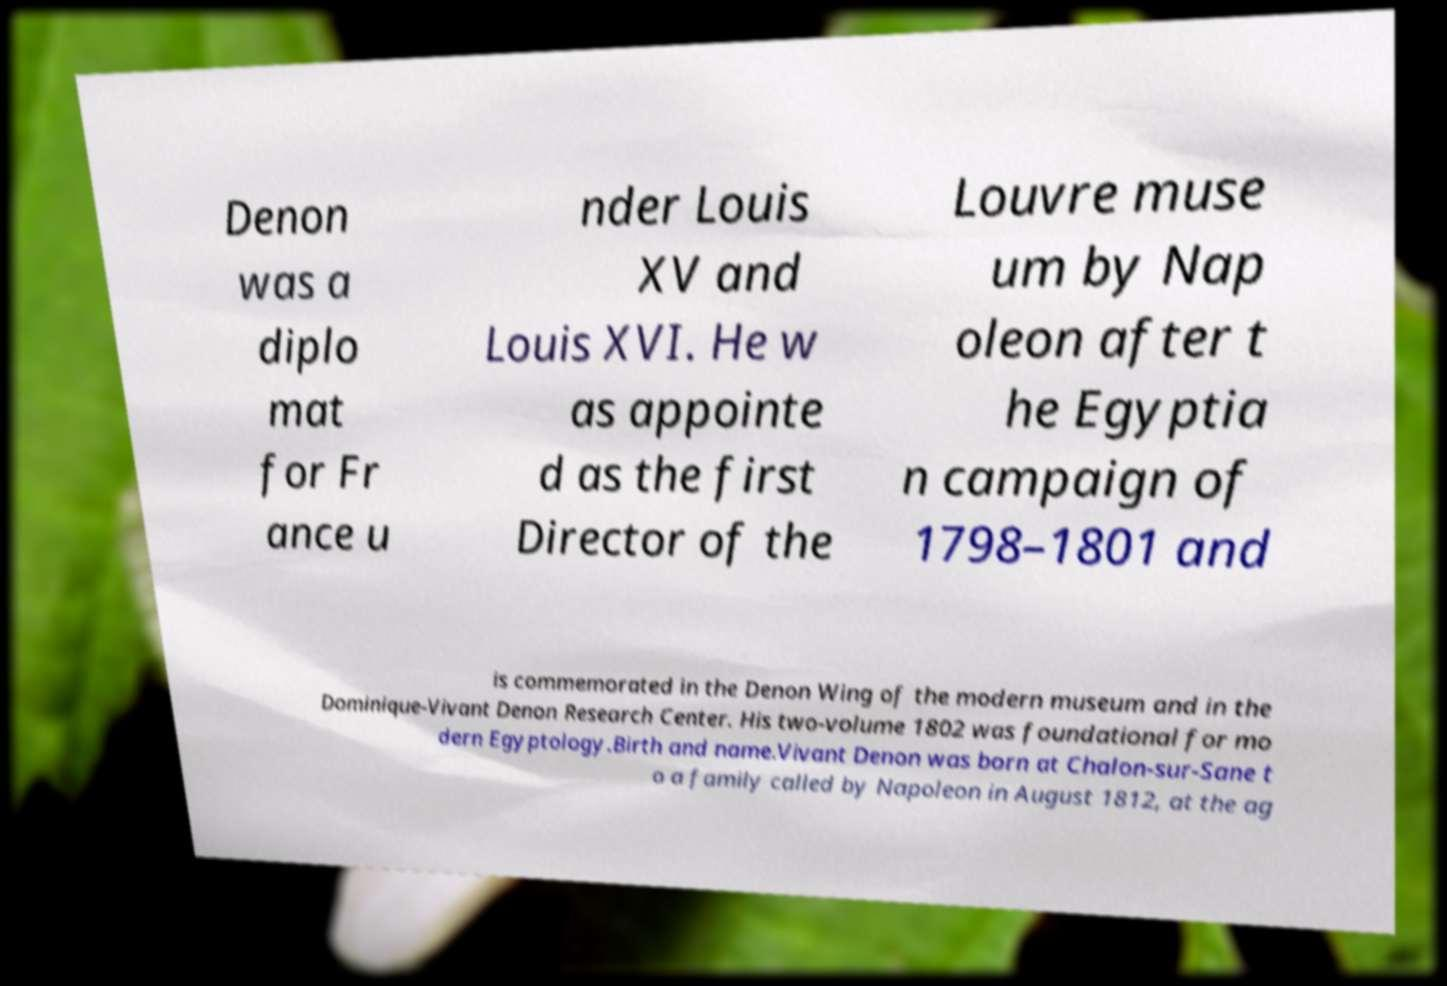Can you accurately transcribe the text from the provided image for me? Denon was a diplo mat for Fr ance u nder Louis XV and Louis XVI. He w as appointe d as the first Director of the Louvre muse um by Nap oleon after t he Egyptia n campaign of 1798–1801 and is commemorated in the Denon Wing of the modern museum and in the Dominique-Vivant Denon Research Center. His two-volume 1802 was foundational for mo dern Egyptology.Birth and name.Vivant Denon was born at Chalon-sur-Sane t o a family called by Napoleon in August 1812, at the ag 